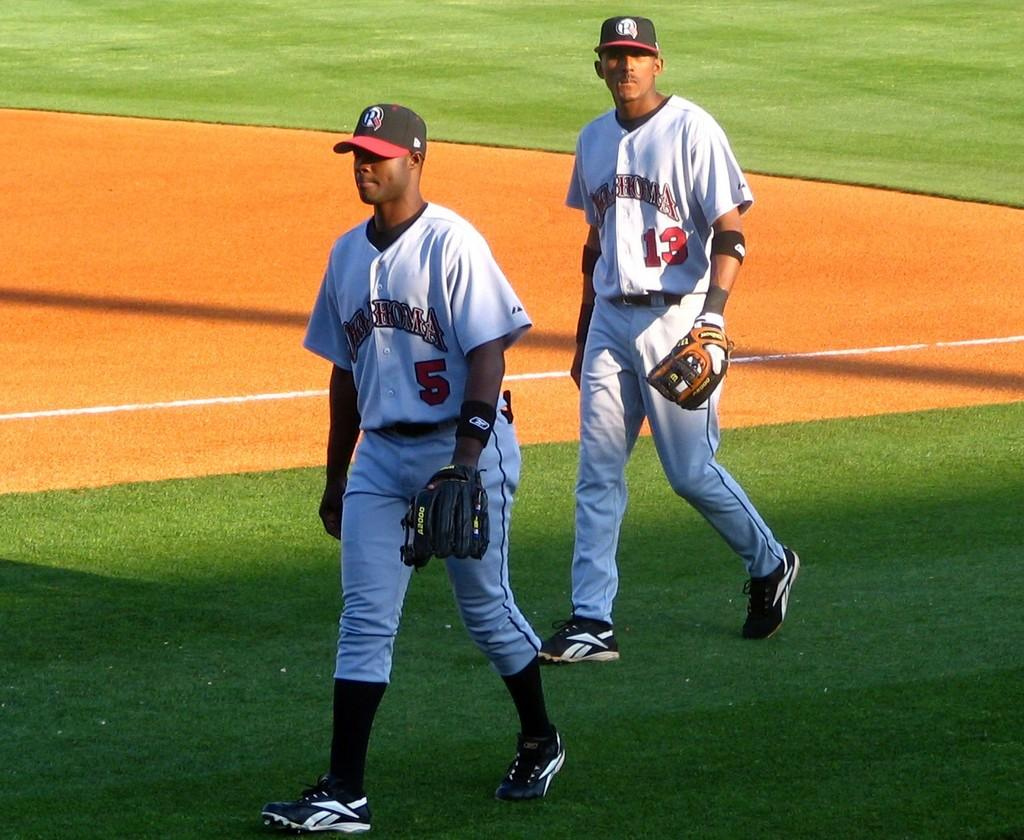<image>
Present a compact description of the photo's key features. a couple people wearing jerseys with one that is wearing the number 5 